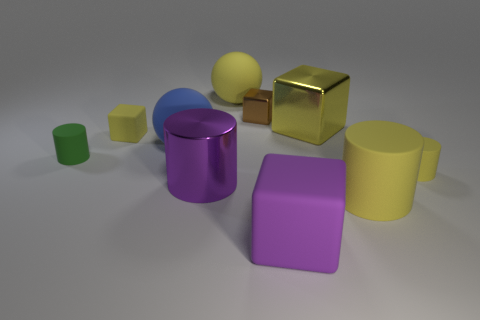There is a purple cylinder that is the same size as the purple rubber block; what material is it?
Ensure brevity in your answer.  Metal. Are there more large things than big yellow metal blocks?
Your answer should be very brief. Yes. What is the size of the matte thing that is left of the small yellow rubber object that is to the left of the tiny brown metallic object?
Make the answer very short. Small. There is a blue matte object that is the same size as the purple matte thing; what shape is it?
Your answer should be very brief. Sphere. There is a small rubber object that is right of the small cube behind the yellow rubber thing that is on the left side of the big yellow sphere; what shape is it?
Your response must be concise. Cylinder. There is a tiny rubber cylinder right of the purple rubber cube; is it the same color as the cube that is to the left of the blue matte ball?
Give a very brief answer. Yes. What number of matte objects are there?
Make the answer very short. 7. Are there any big things behind the large blue object?
Make the answer very short. Yes. Does the big cylinder that is to the left of the brown object have the same material as the small cylinder that is to the left of the purple matte object?
Ensure brevity in your answer.  No. Are there fewer big cylinders to the left of the large yellow cylinder than matte balls?
Offer a very short reply. Yes. 